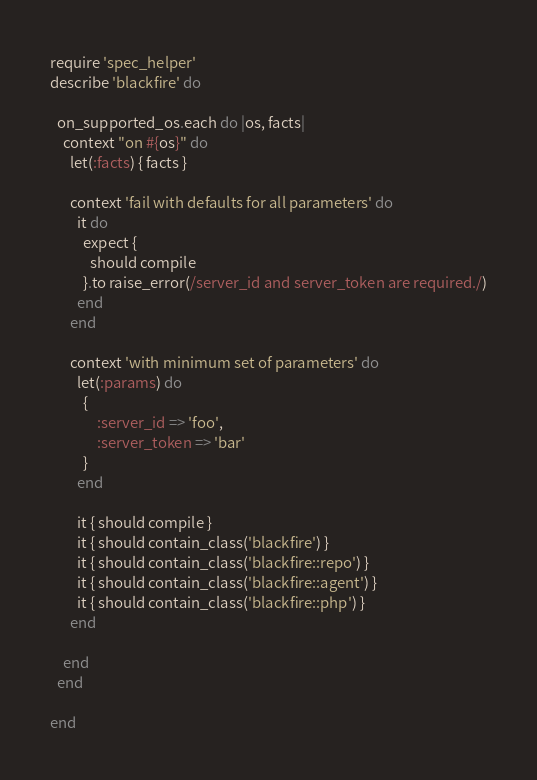Convert code to text. <code><loc_0><loc_0><loc_500><loc_500><_Ruby_>require 'spec_helper'
describe 'blackfire' do

  on_supported_os.each do |os, facts|
    context "on #{os}" do
      let(:facts) { facts }

      context 'fail with defaults for all parameters' do
        it do
          expect {
            should compile
          }.to raise_error(/server_id and server_token are required./)
        end
      end

      context 'with minimum set of parameters' do
        let(:params) do
          {
              :server_id => 'foo',
              :server_token => 'bar'
          }
        end

        it { should compile }
        it { should contain_class('blackfire') }
        it { should contain_class('blackfire::repo') }
        it { should contain_class('blackfire::agent') }
        it { should contain_class('blackfire::php') }
      end

    end
  end

end
</code> 